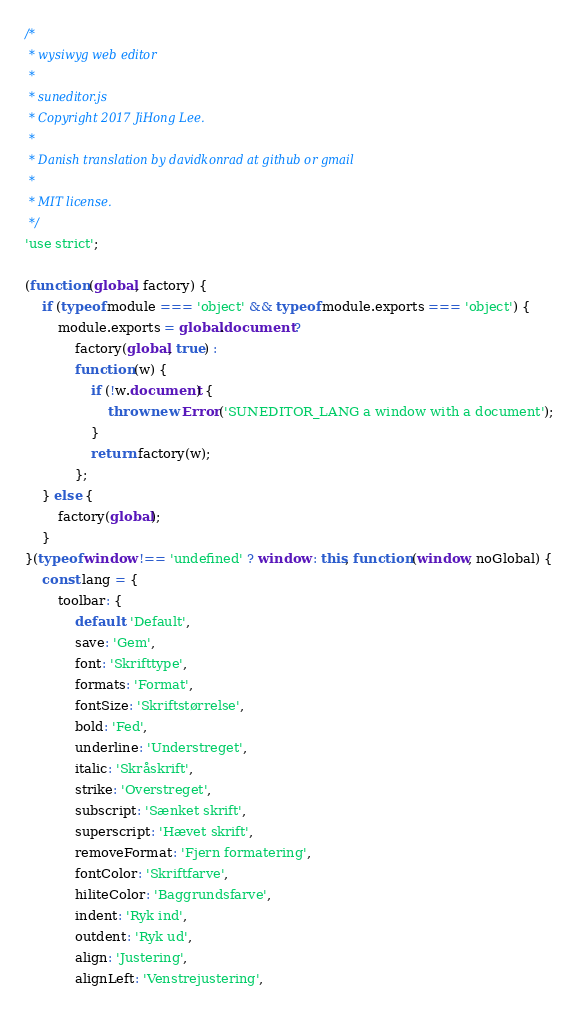<code> <loc_0><loc_0><loc_500><loc_500><_JavaScript_>/*
 * wysiwyg web editor
 *
 * suneditor.js
 * Copyright 2017 JiHong Lee.
 * 
 * Danish translation by davidkonrad at github or gmail
 *
 * MIT license.
 */
'use strict';

(function (global, factory) {
    if (typeof module === 'object' && typeof module.exports === 'object') {
        module.exports = global.document ?
            factory(global, true) :
            function (w) {
                if (!w.document) {
                    throw new Error('SUNEDITOR_LANG a window with a document');
                }
                return factory(w);
            };
    } else {
        factory(global);
    }
}(typeof window !== 'undefined' ? window : this, function (window, noGlobal) {
    const lang = {
        toolbar: {
            default: 'Default',
            save: 'Gem',
            font: 'Skrifttype',
            formats: 'Format',
            fontSize: 'Skriftstørrelse',
            bold: 'Fed',
            underline: 'Understreget',
            italic: 'Skråskrift',
            strike: 'Overstreget',
            subscript: 'Sænket skrift',
            superscript: 'Hævet skrift',
            removeFormat: 'Fjern formatering',
            fontColor: 'Skriftfarve',
            hiliteColor: 'Baggrundsfarve',
            indent: 'Ryk ind',
            outdent: 'Ryk ud',
            align: 'Justering',
            alignLeft: 'Venstrejustering',</code> 